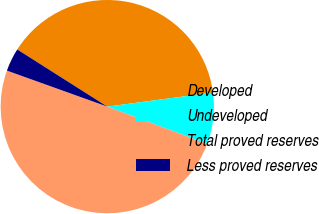Convert chart to OTSL. <chart><loc_0><loc_0><loc_500><loc_500><pie_chart><fcel>Developed<fcel>Undeveloped<fcel>Total proved reserves<fcel>Less proved reserves<nl><fcel>38.89%<fcel>7.8%<fcel>49.79%<fcel>3.52%<nl></chart> 